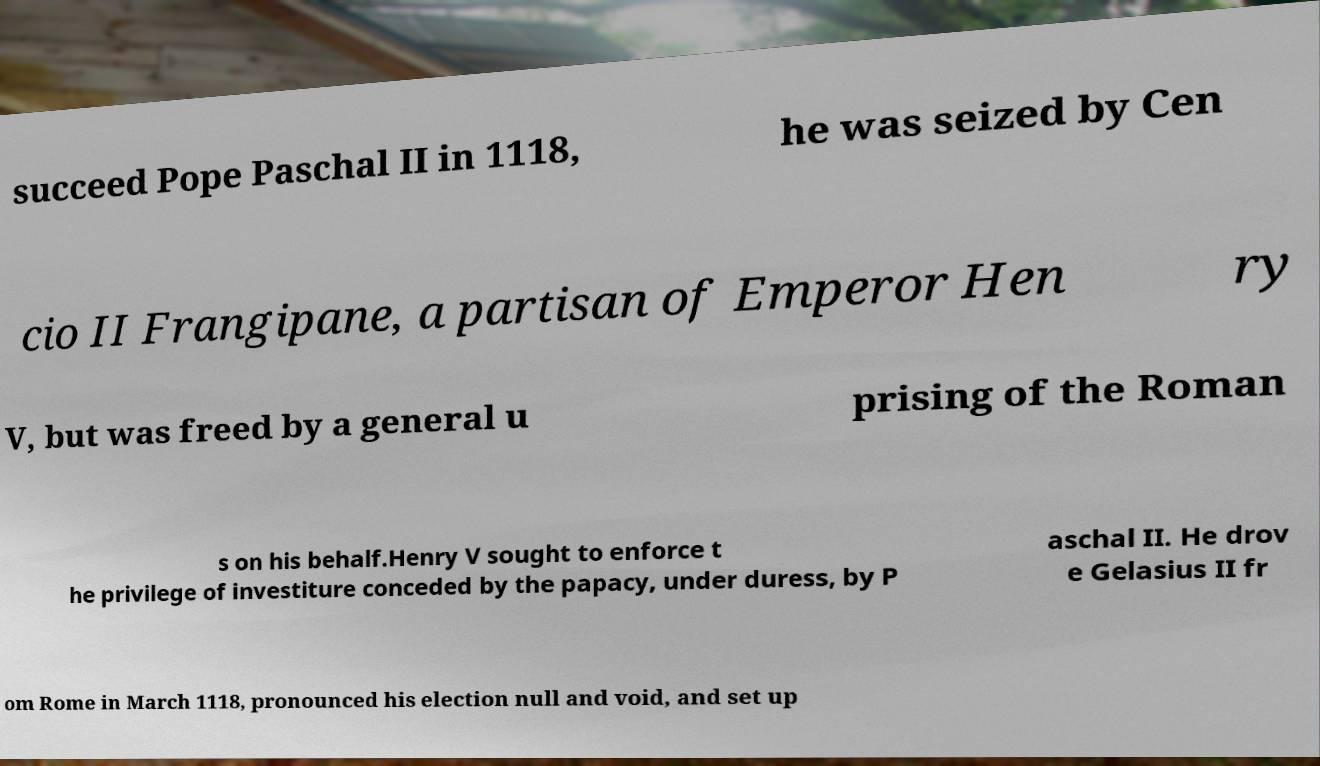There's text embedded in this image that I need extracted. Can you transcribe it verbatim? succeed Pope Paschal II in 1118, he was seized by Cen cio II Frangipane, a partisan of Emperor Hen ry V, but was freed by a general u prising of the Roman s on his behalf.Henry V sought to enforce t he privilege of investiture conceded by the papacy, under duress, by P aschal II. He drov e Gelasius II fr om Rome in March 1118, pronounced his election null and void, and set up 